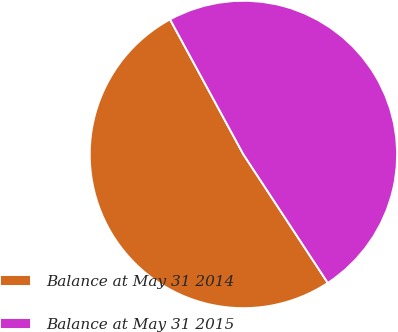<chart> <loc_0><loc_0><loc_500><loc_500><pie_chart><fcel>Balance at May 31 2014<fcel>Balance at May 31 2015<nl><fcel>51.33%<fcel>48.67%<nl></chart> 